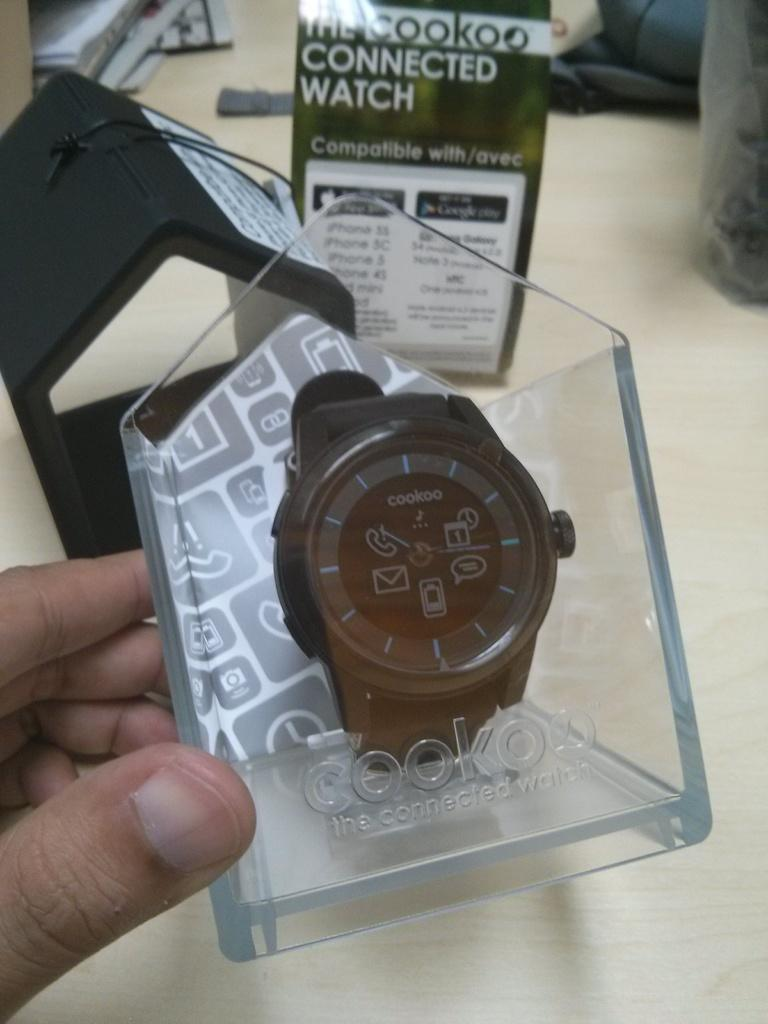<image>
Provide a brief description of the given image. A cookoo brand watch is displayed in its packaging. 